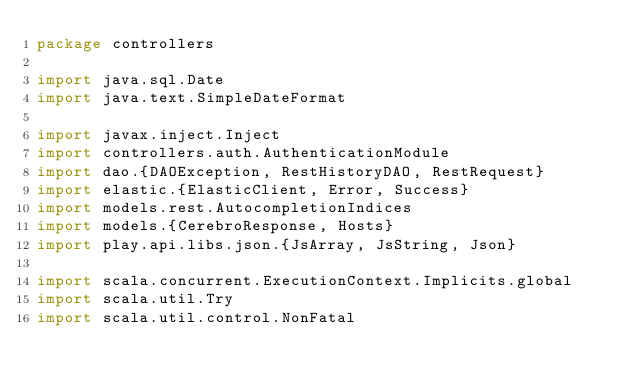Convert code to text. <code><loc_0><loc_0><loc_500><loc_500><_Scala_>package controllers

import java.sql.Date
import java.text.SimpleDateFormat

import javax.inject.Inject
import controllers.auth.AuthenticationModule
import dao.{DAOException, RestHistoryDAO, RestRequest}
import elastic.{ElasticClient, Error, Success}
import models.rest.AutocompletionIndices
import models.{CerebroResponse, Hosts}
import play.api.libs.json.{JsArray, JsString, Json}

import scala.concurrent.ExecutionContext.Implicits.global
import scala.util.Try
import scala.util.control.NonFatal</code> 